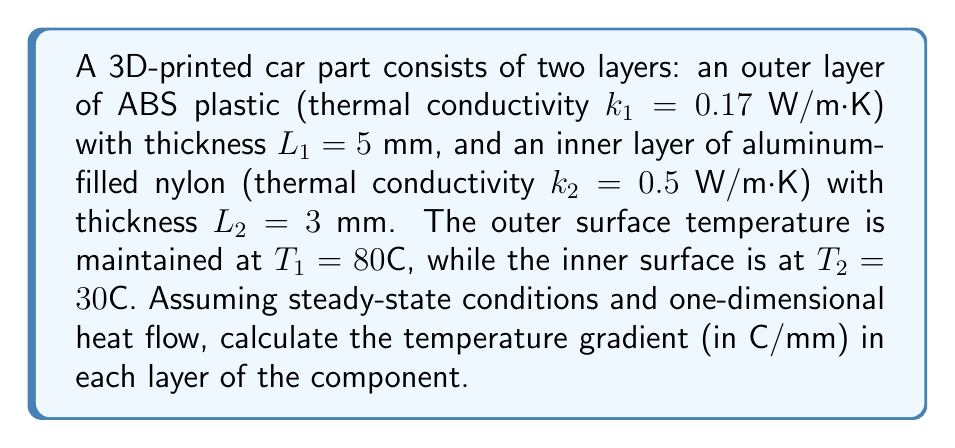Provide a solution to this math problem. To solve this problem, we'll use Fourier's law of heat conduction and the concept of thermal resistance. We'll follow these steps:

1) In steady-state, one-dimensional heat flow, the heat flux ($q$) is constant throughout the component. We can express this as:

   $$q = -k_1 \frac{dT_1}{dx} = -k_2 \frac{dT_2}{dx}$$

2) We can also express the total temperature difference as the sum of the temperature drops across each layer:

   $$T_1 - T_2 = \Delta T_1 + \Delta T_2$$

3) Using the thermal resistance concept, we can write:

   $$\Delta T_1 = q \frac{L_1}{k_1}$$ and $$\Delta T_2 = q \frac{L_2}{k_2}$$

4) Substituting these into the total temperature difference equation:

   $$T_1 - T_2 = q(\frac{L_1}{k_1} + \frac{L_2}{k_2})$$

5) Solving for $q$:

   $$q = \frac{T_1 - T_2}{\frac{L_1}{k_1} + \frac{L_2}{k_2}} = \frac{80 - 30}{\frac{0.005}{0.17} + \frac{0.003}{0.5}} = 4000 \text{ W/m}^2$$

6) Now we can calculate the temperature gradients:

   For ABS (outer layer): $$\frac{dT_1}{dx} = -\frac{q}{k_1} = -\frac{4000}{0.17} = -23529.41 \text{ K/m} = -23.53 \text{ °C/mm}$$

   For aluminum-filled nylon (inner layer): $$\frac{dT_2}{dx} = -\frac{q}{k_2} = -\frac{4000}{0.5} = -8000 \text{ K/m} = -8 \text{ °C/mm}$$
Answer: Outer layer (ABS): -23.53 °C/mm; Inner layer (Al-filled nylon): -8 °C/mm 